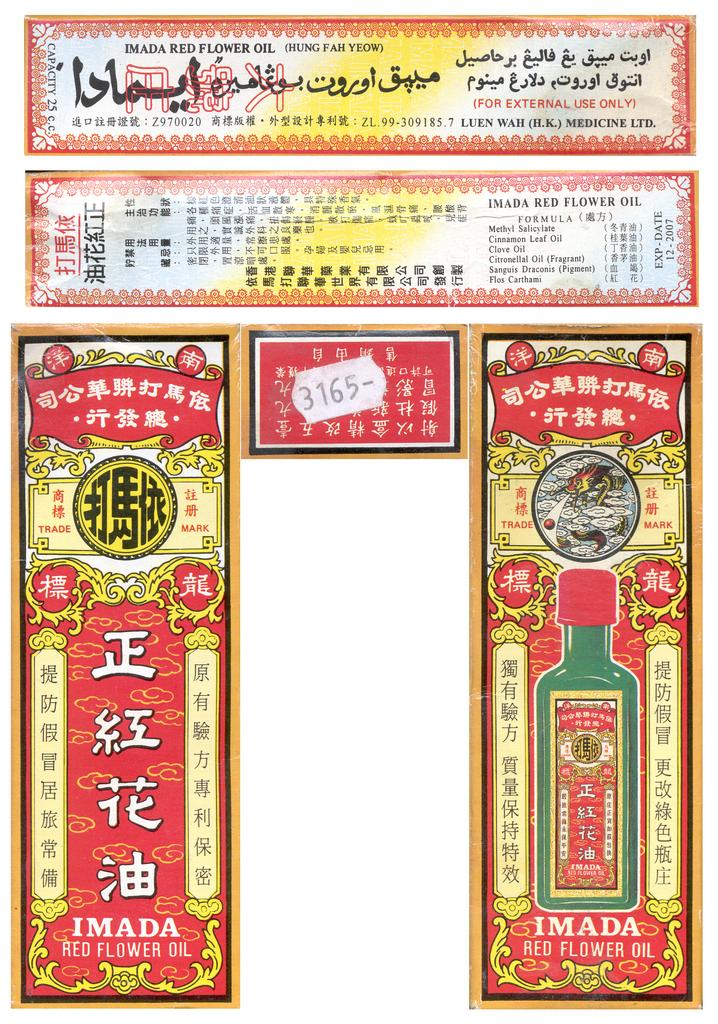<image>
Offer a succinct explanation of the picture presented. colorful ads for something called  Imada Red Flower Oil 